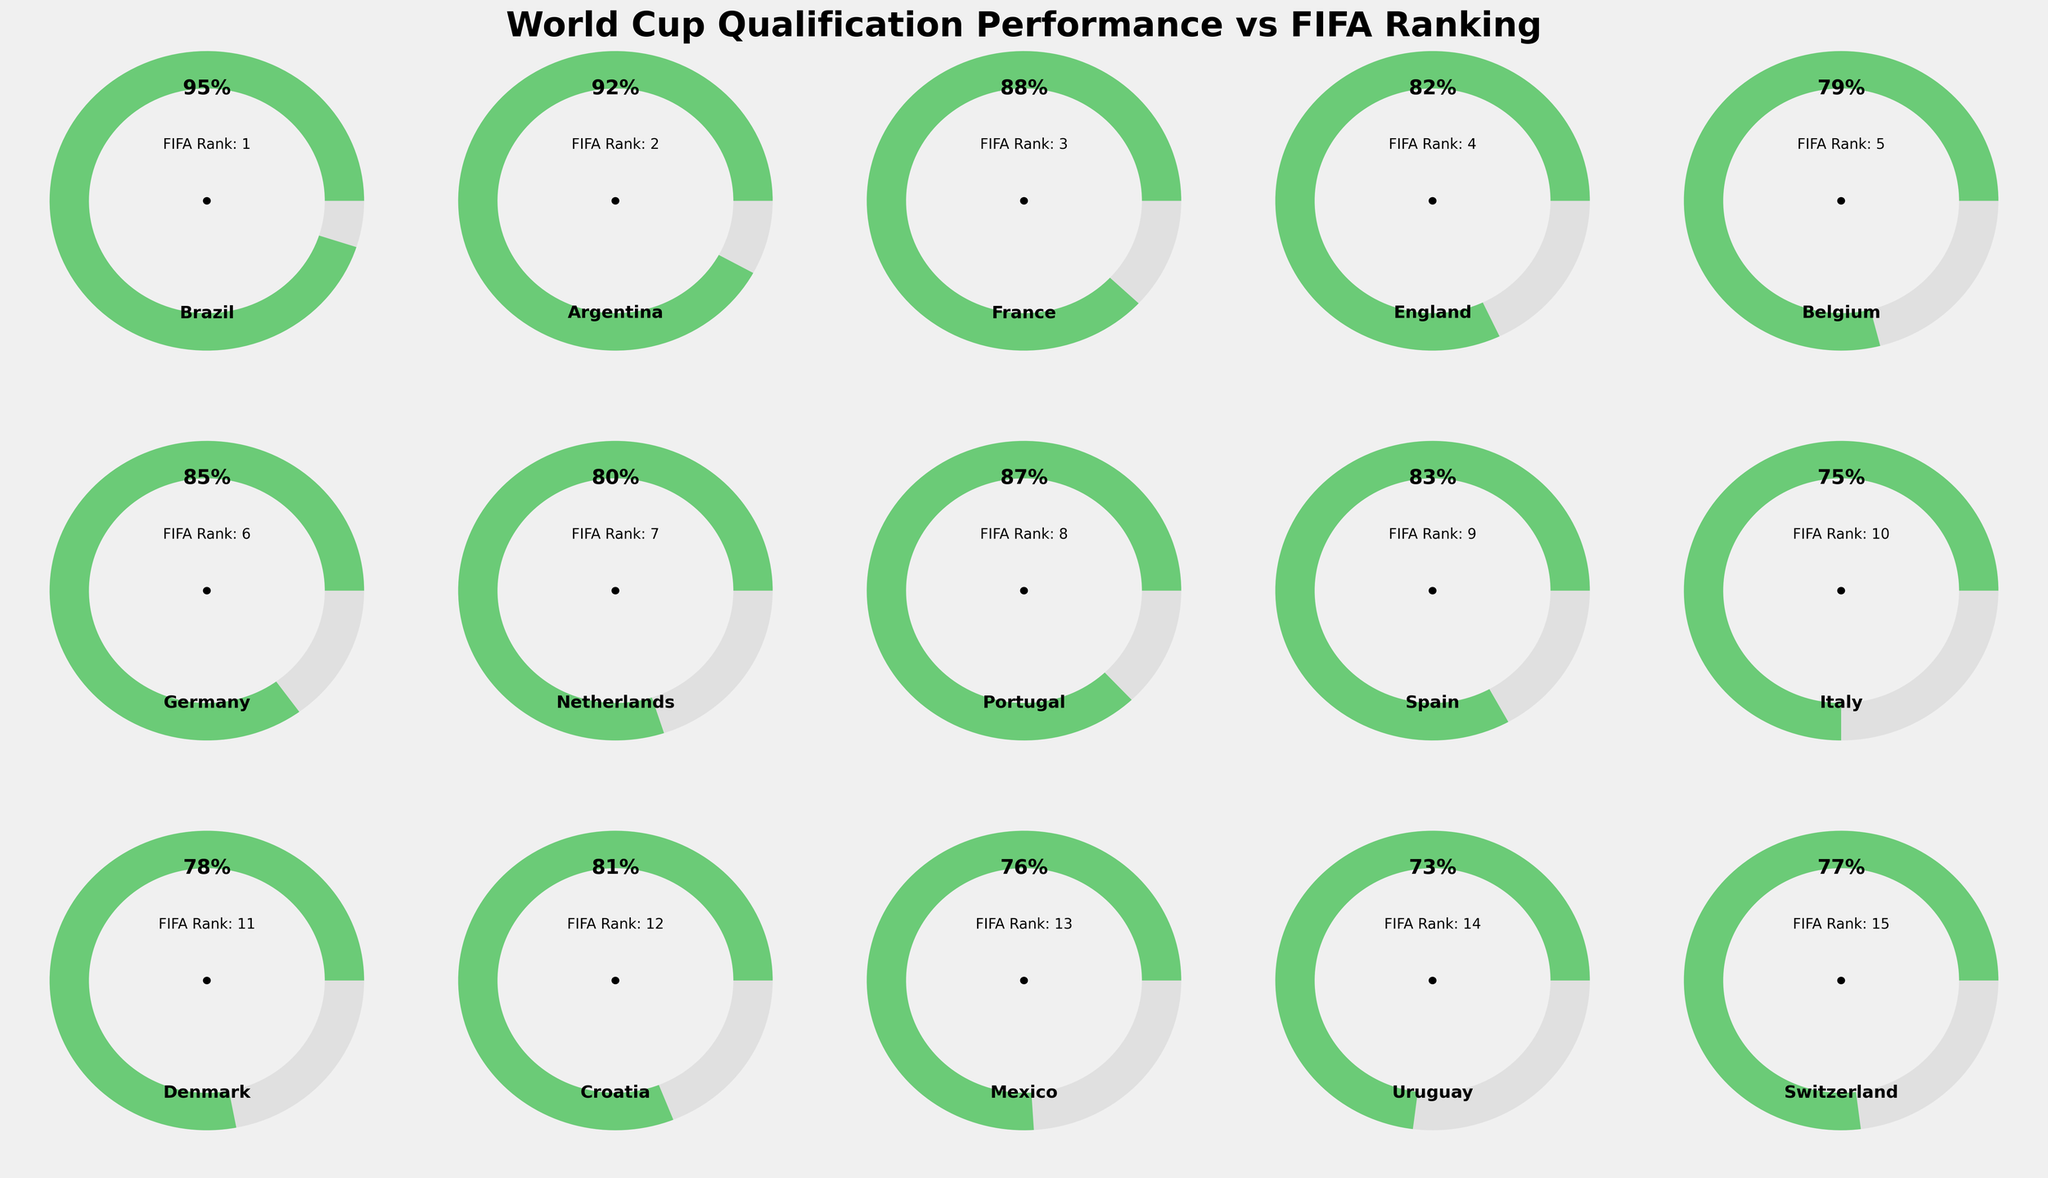Which team has the highest qualification performance? According to the gauge chart, Brazil's gauge shows a 95% qualification performance, which is the highest among all teams represented.
Answer: Brazil How does Germany's qualification performance compare to Portugal's? Germany's qualification performance is 85%, while Portugal's is 87%, as seen on their respective gauge charts. Comparing the two, Portugal's performance is slightly higher.
Answer: Portugal's is higher What is the range of qualification performances shown in the gauge charts? The lowest qualification performance shown is for Uruguay at 73%, and the highest is for Brazil at 95%. The difference between these two values gives the range: 95 - 73 = 22%.
Answer: 22% Which teams have a qualification performance of 80% or more? Reviewing the gauge charts, the teams with 80% or more qualification performance are Brazil (95%), Argentina (92%), France (88%), England (82%), Germany (85%), Portugal (87%), Spain (83%), and Croatia (81%).
Answer: Brazil, Argentina, France, England, Germany, Portugal, Spain, Croatia What is the median qualification performance of the teams? To find the median, list the qualification performances in ascending order: 73, 75, 76, 77, 78, 79, 80, 81, 82, 83, 85, 87, 88, 92, 95. The middle value in this ordered list is 81, which is Croatia's performance.
Answer: 81 Compare the qualification performances of teams ranked 1st and 15th by FIFA. Brazil, ranked 1st, has a 95% qualification performance, while Switzerland, ranked 15th, has a 77% qualification performance. Brazil's performance is significantly higher than Switzerland's.
Answer: Brazil's is higher Which team has the lowest qualification performance? By looking at the gauge charts, Uruguay has the lowest qualification performance at 73%.
Answer: Uruguay Are there any teams with the same qualification performance? Reviewing the gauge charts, no two teams have identical qualification performances. Each team's percentage is unique.
Answer: No What color is used to indicate the highest qualification performance range? The highest qualification performance range (around 90% and above) is colored green.
Answer: Green How many teams are there with a qualification performance lower than 80%? The teams with qualification performance lower than 80% are Belgium (79%), Italy (75%), Denmark (78%), Mexico (76%), Uruguay (73%), and Switzerland (77%). This totals to 6 teams.
Answer: 6 